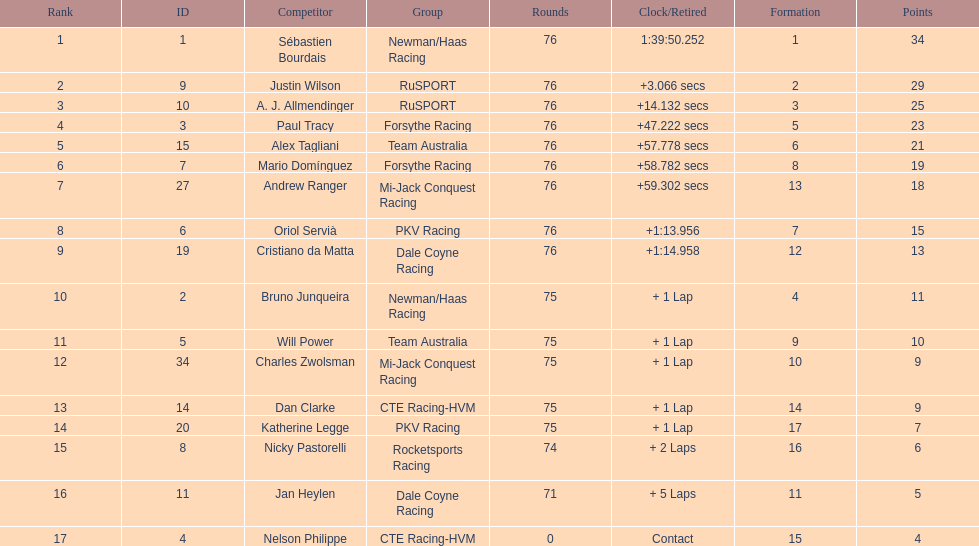What driver earned the most points? Sebastien Bourdais. 